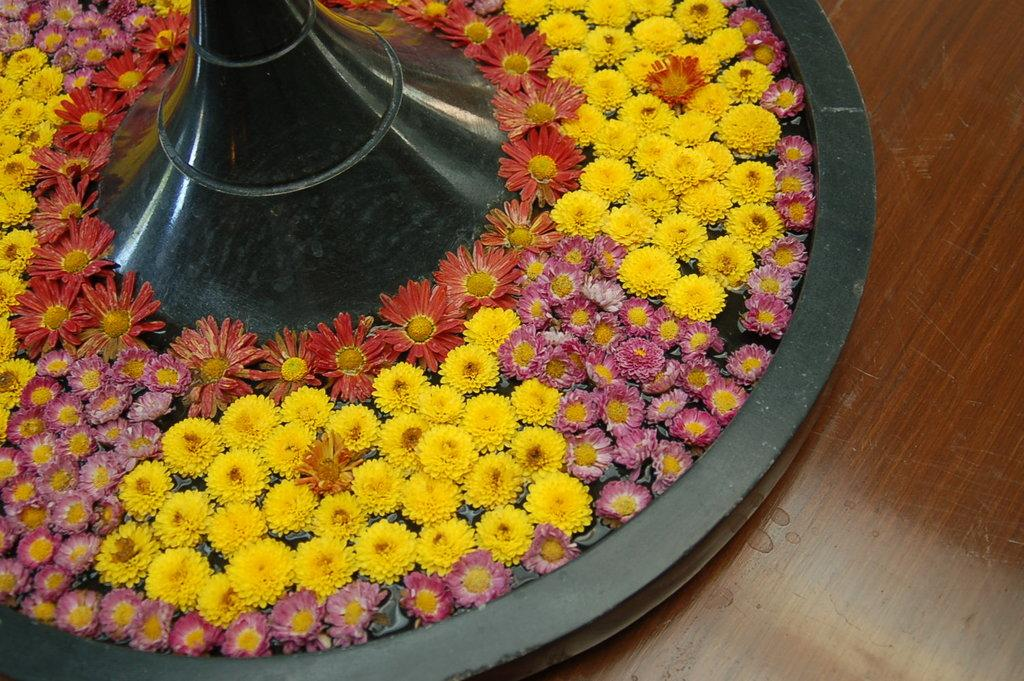What type of objects can be seen in the image? There are flowers in the image. How are the flowers arranged or displayed? The flowers are in a plate. What type of hand can be seen holding the flowers in the image? There is no hand visible in the image; the flowers are in a plate. What type of lunch is being served with the flowers in the image? There is no lunch present in the image; it only features flowers in a plate. 